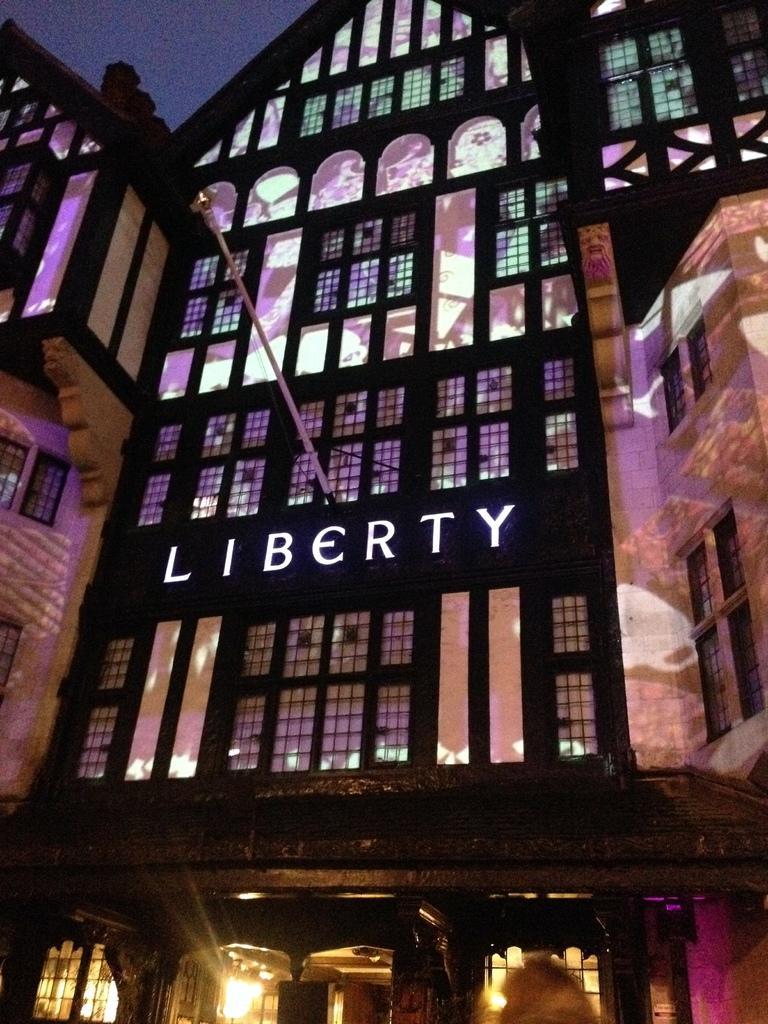Please provide a concise description of this image. In this image we can see a building with some text, there are some windows, doors, lights and a pole. 